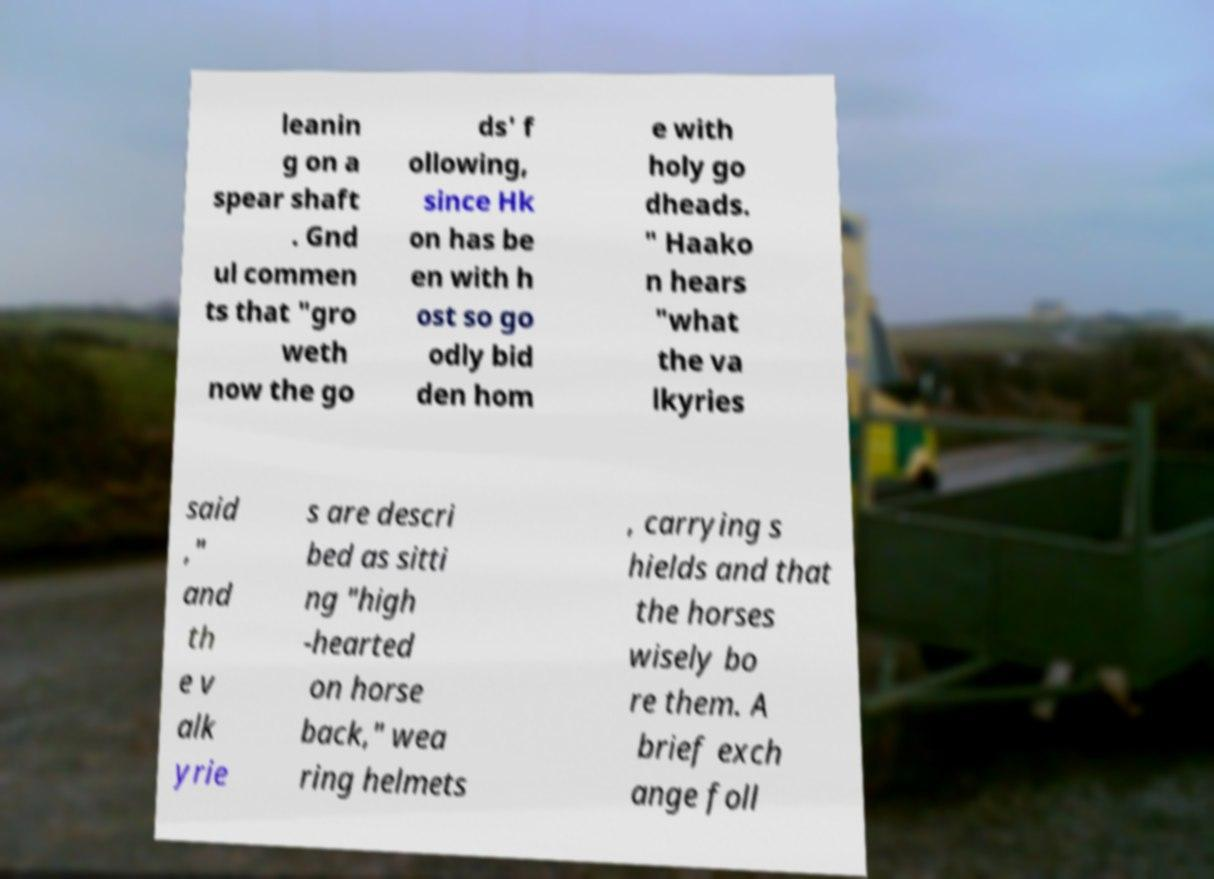Can you accurately transcribe the text from the provided image for me? leanin g on a spear shaft . Gnd ul commen ts that "gro weth now the go ds' f ollowing, since Hk on has be en with h ost so go odly bid den hom e with holy go dheads. " Haako n hears "what the va lkyries said ," and th e v alk yrie s are descri bed as sitti ng "high -hearted on horse back," wea ring helmets , carrying s hields and that the horses wisely bo re them. A brief exch ange foll 